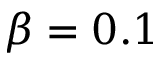Convert formula to latex. <formula><loc_0><loc_0><loc_500><loc_500>\beta = 0 . 1</formula> 